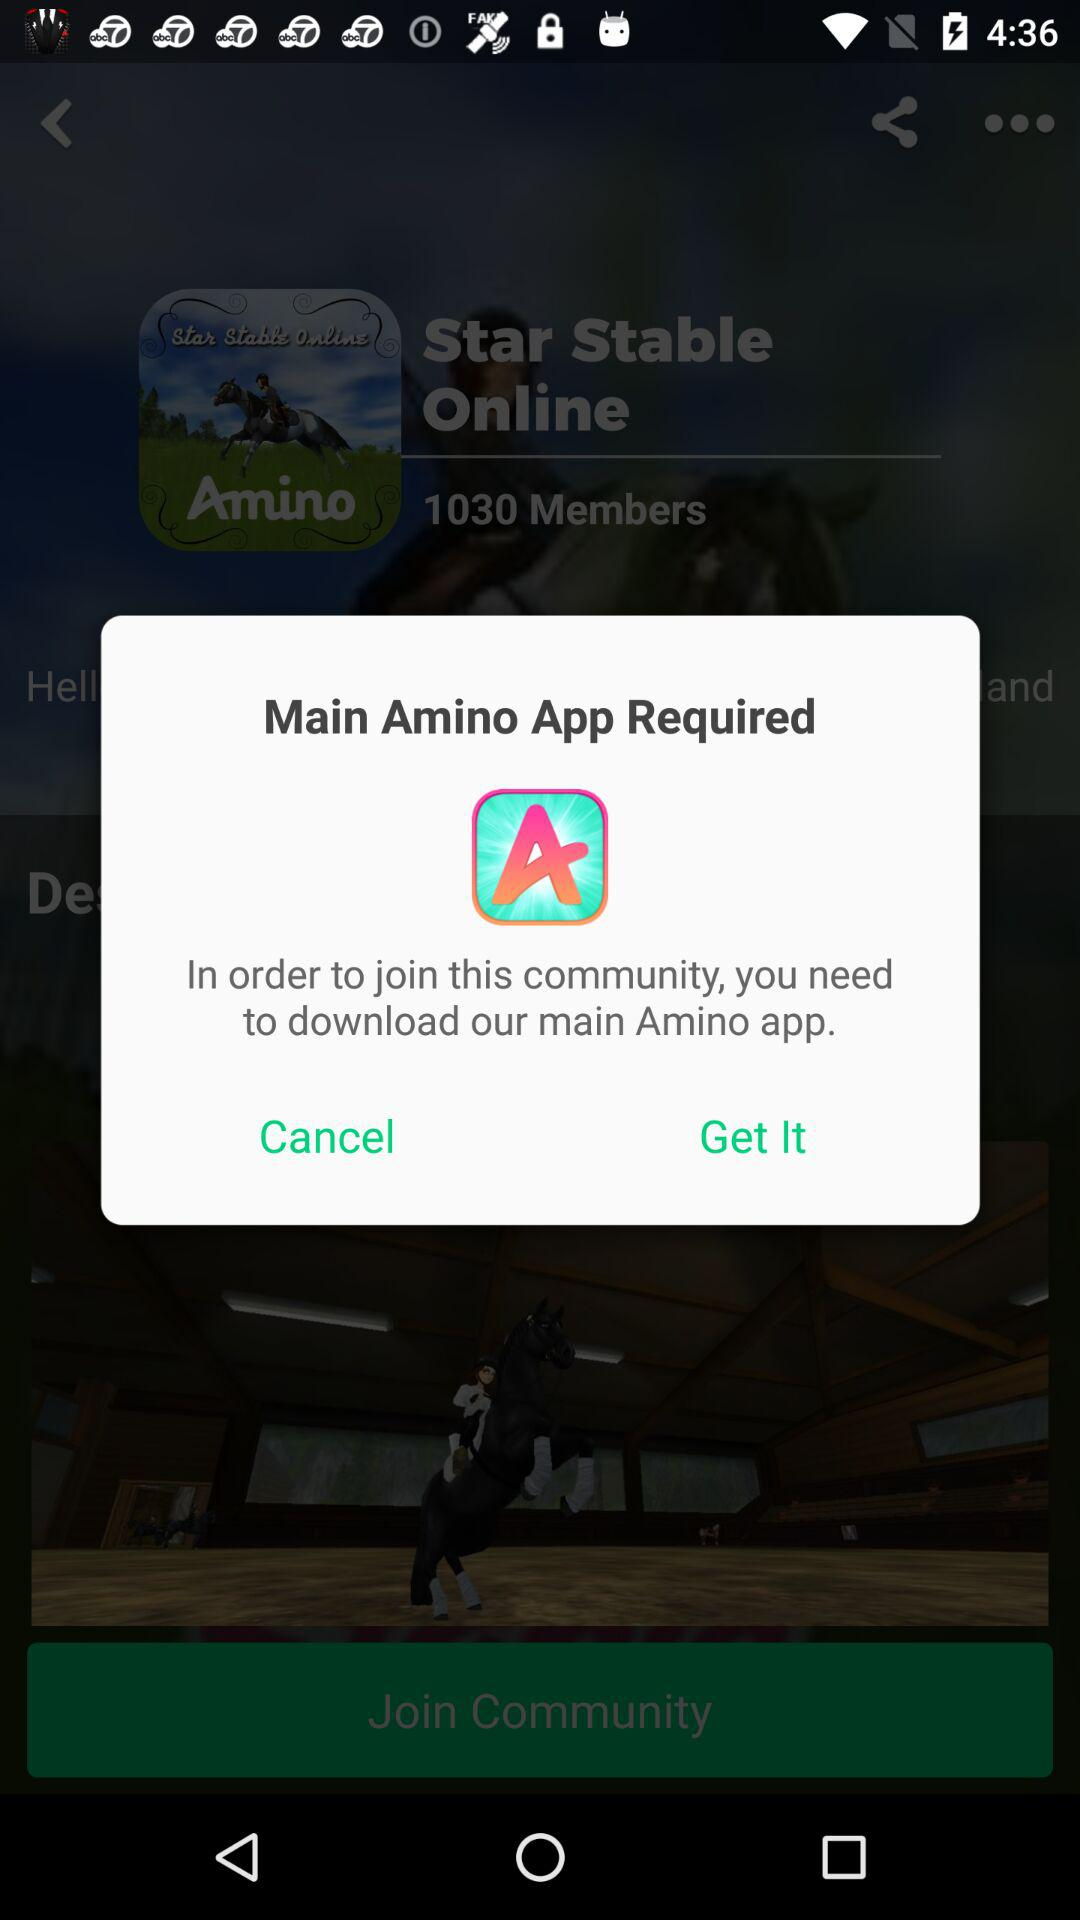What is the user's name?
When the provided information is insufficient, respond with <no answer>. <no answer> 